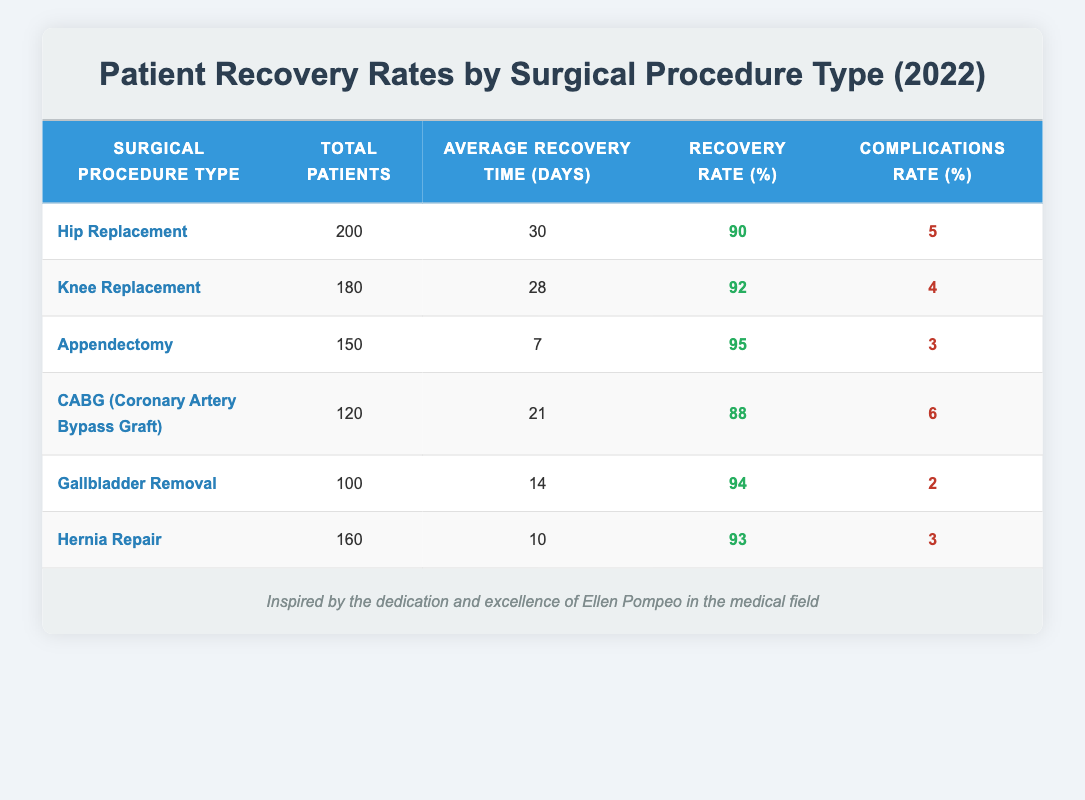What is the recovery rate for Hip Replacement surgeries? The recovery rate is listed in the table next to the Hip Replacement entry, which shows a recovery rate of 90%.
Answer: 90 How many total patients underwent Knee Replacement? The total number of patients for Knee Replacement can be found in the corresponding row of the table, showing 180 total patients.
Answer: 180 What surgical procedure has the highest recovery rate? To find the highest recovery rate, I compared all the rates in the table. The highest rate is 95% for Appendectomy.
Answer: Appendectomy What is the average recovery time for Gallbladder Removal? Looking at the table, the average recovery time listed for Gallbladder Removal is 14 days.
Answer: 14 days Calculate the average recovery time for all procedures. First, sum up the average recovery times: (30 + 28 + 7 + 21 + 14 + 10) = 110 days. Then divide by the number of procedures, which is 6. Therefore, the average recovery time is 110/6 = 18.33 days.
Answer: 18.33 days Is the complications rate for Knee Replacement lower than that for CABG? In the table, the complications rate for Knee Replacement is 4% while for CABG it is 6%. Since 4% is lower than 6%, the statement is true.
Answer: Yes What is the total number of patients for all surgical procedures combined? To find the total number of patients, I need to sum the total patients for each procedure from the table: (200 + 180 + 150 + 120 + 100 + 160) = 1010.
Answer: 1010 Which procedure type had the lowest complications rate? By inspecting the complications rates, Gallbladder Removal has the lowest rate of 2%, compared to the others.
Answer: Gallbladder Removal How much longer on average do patients take to recover after Hip Replacement compared to Hernia Repair? The average recovery time for Hip Replacement is 30 days and for Hernia Repair is 10 days. The difference is 30 - 10 = 20 days, meaning Hip Replacement takes 20 days longer.
Answer: 20 days 